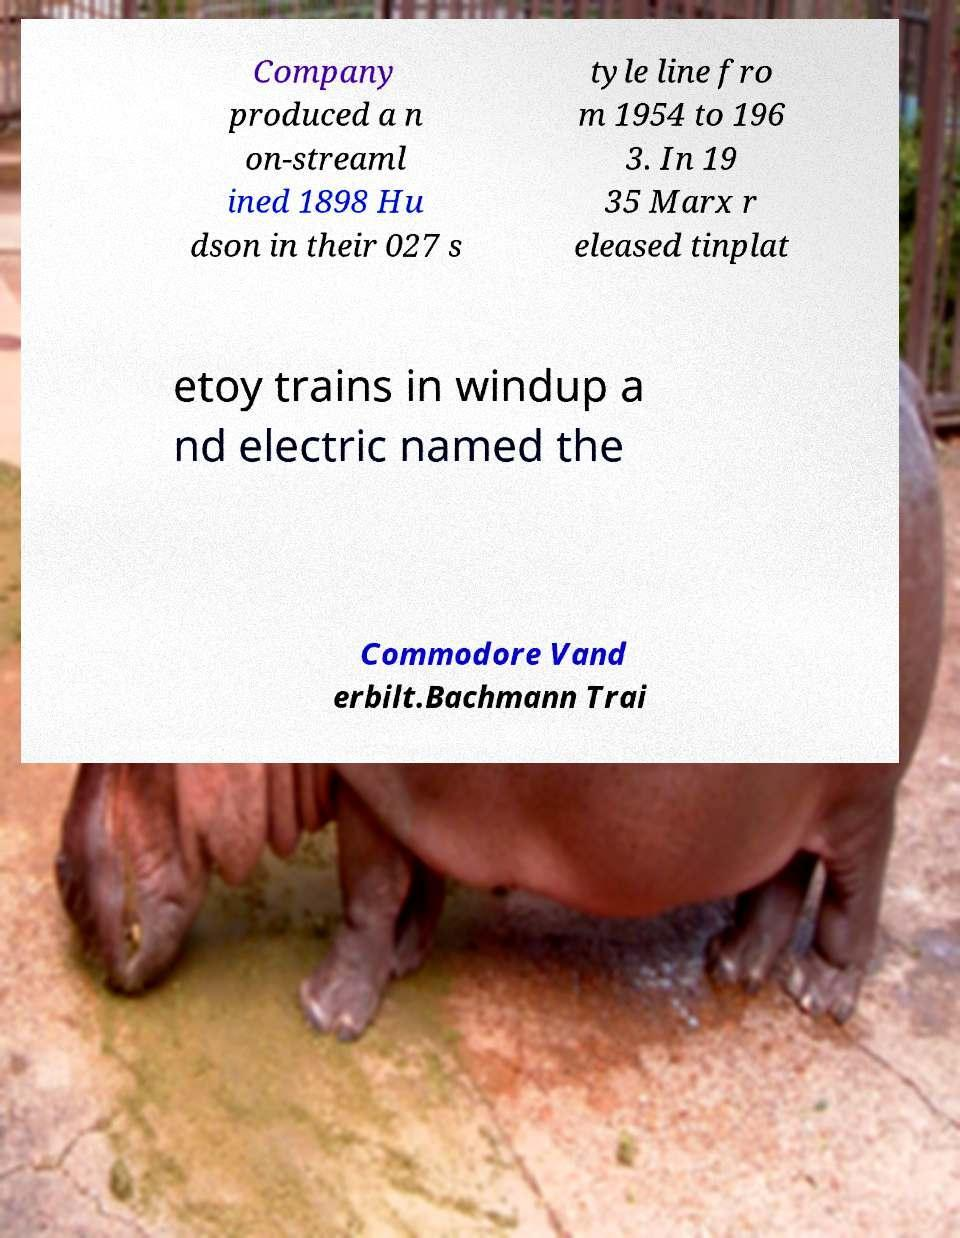Please read and relay the text visible in this image. What does it say? Company produced a n on-streaml ined 1898 Hu dson in their 027 s tyle line fro m 1954 to 196 3. In 19 35 Marx r eleased tinplat etoy trains in windup a nd electric named the Commodore Vand erbilt.Bachmann Trai 